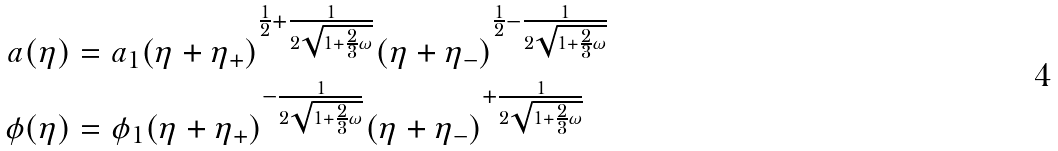<formula> <loc_0><loc_0><loc_500><loc_500>a ( \eta ) & = a _ { 1 } ( \eta + \eta _ { + } ) ^ { \frac { 1 } { 2 } + \frac { 1 } { 2 \sqrt { 1 + \frac { 2 } { 3 } \omega } } } ( \eta + \eta _ { - } ) ^ { \frac { 1 } { 2 } - \frac { 1 } { 2 \sqrt { 1 + \frac { 2 } { 3 } \omega } } } \\ \phi ( \eta ) & = \phi _ { 1 } ( \eta + \eta _ { + } ) ^ { - \frac { 1 } { 2 \sqrt { 1 + \frac { 2 } { 3 } \omega } } } ( \eta + \eta _ { - } ) ^ { + \frac { 1 } { 2 \sqrt { 1 + \frac { 2 } { 3 } \omega } } }</formula> 